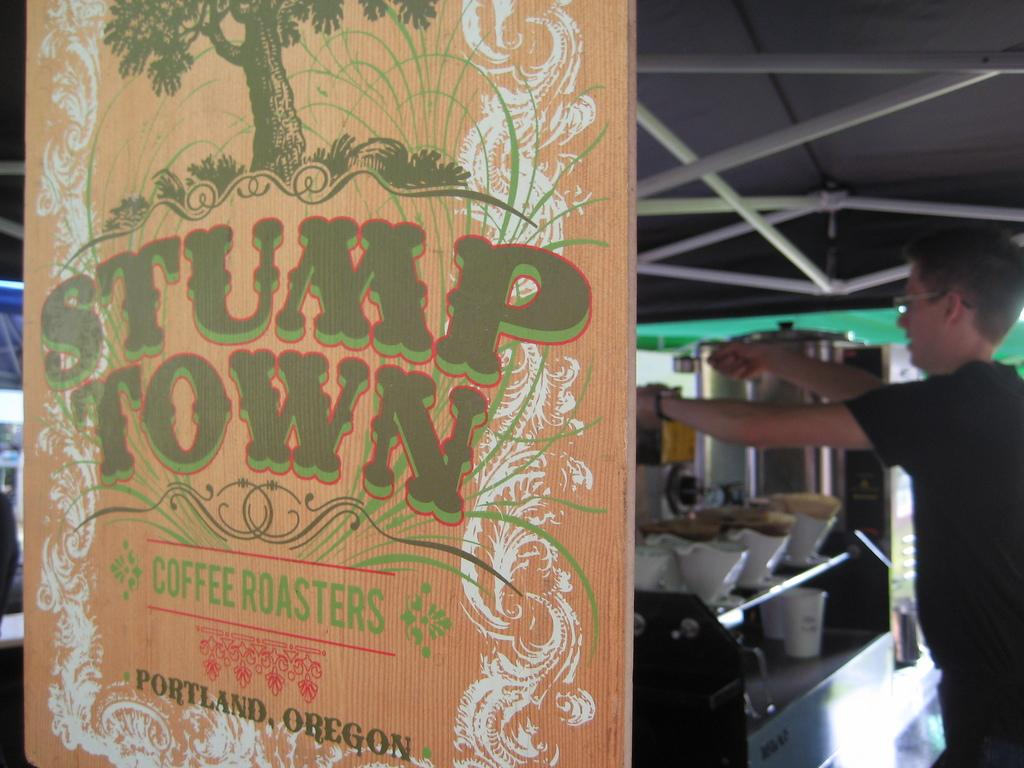<image>
Present a compact description of the photo's key features. A sign that says Stump Town Coffee Roasters. 